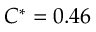<formula> <loc_0><loc_0><loc_500><loc_500>C ^ { * } = 0 . 4 6</formula> 